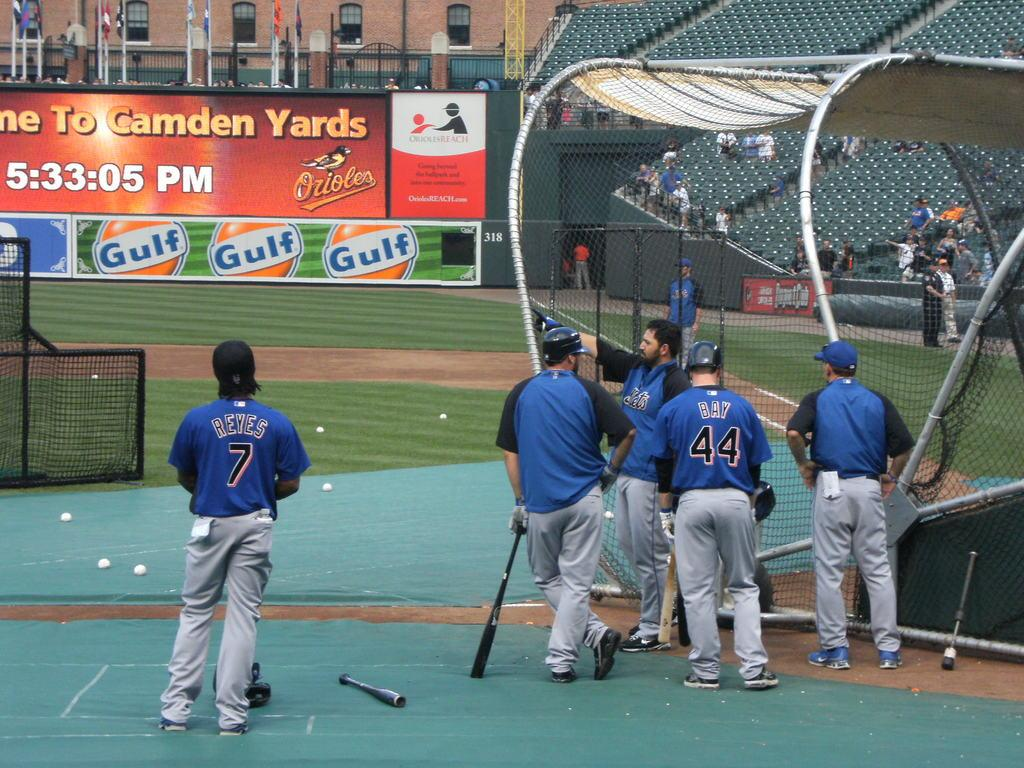<image>
Share a concise interpretation of the image provided. A bunch of baseball players are gathered across from a stadium wall containing ads for Gulf. 